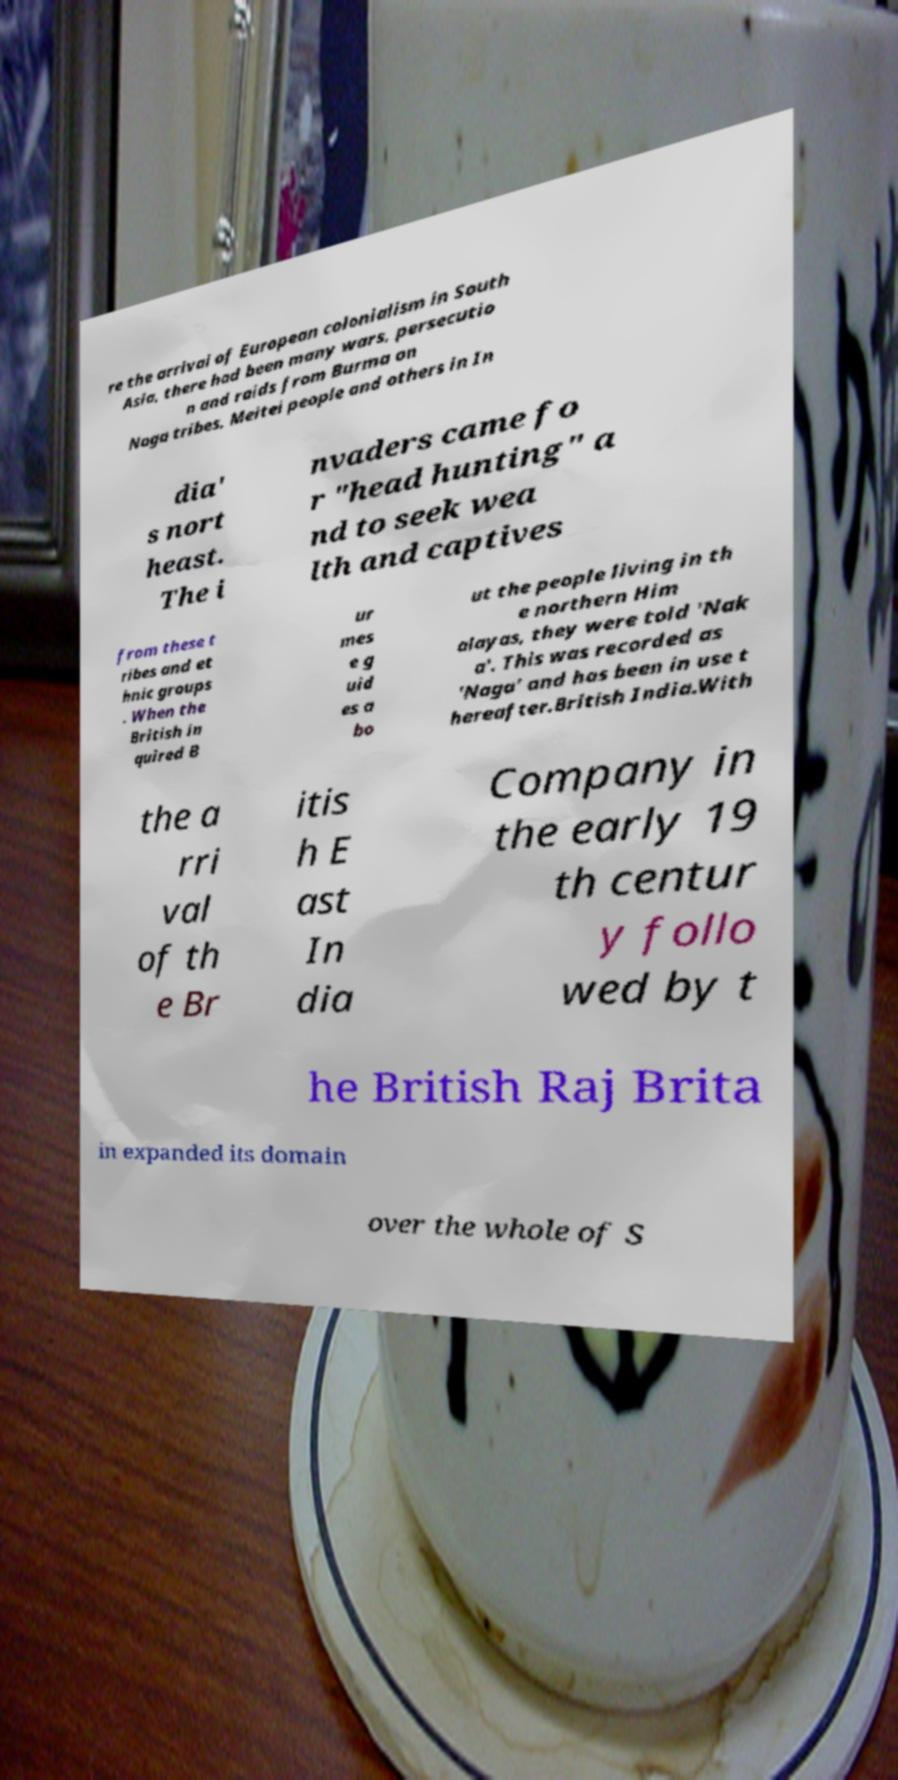Can you read and provide the text displayed in the image?This photo seems to have some interesting text. Can you extract and type it out for me? re the arrival of European colonialism in South Asia, there had been many wars, persecutio n and raids from Burma on Naga tribes, Meitei people and others in In dia' s nort heast. The i nvaders came fo r "head hunting" a nd to seek wea lth and captives from these t ribes and et hnic groups . When the British in quired B ur mes e g uid es a bo ut the people living in th e northern Him alayas, they were told 'Nak a'. This was recorded as 'Naga' and has been in use t hereafter.British India.With the a rri val of th e Br itis h E ast In dia Company in the early 19 th centur y follo wed by t he British Raj Brita in expanded its domain over the whole of S 